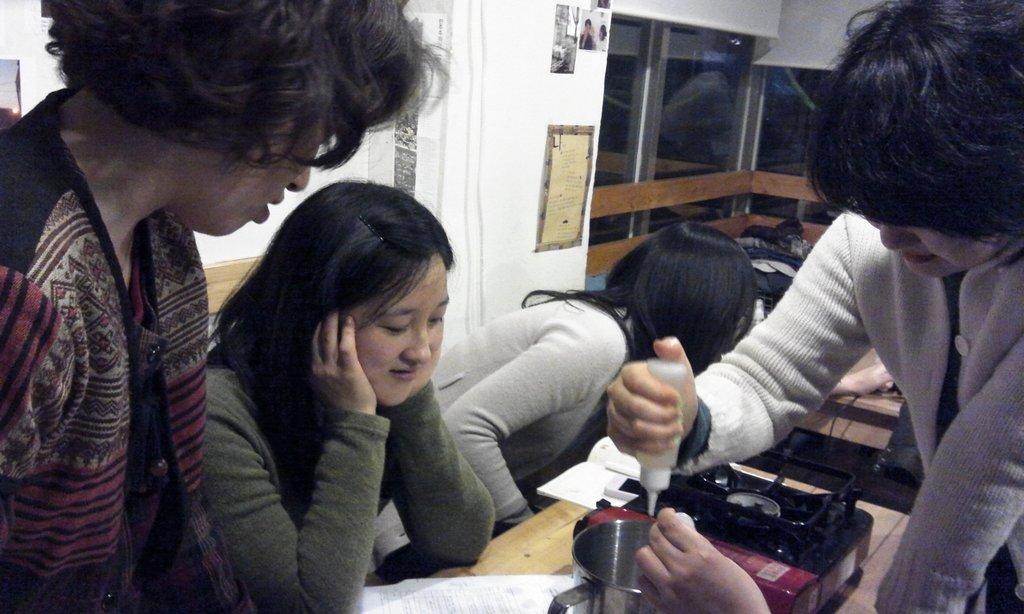In one or two sentences, can you explain what this image depicts? In this image I can see number of people and on the right side I can see one of them is holding a white colour thing. In the centre of this image I can see a table and on it I can see a book, a white colour paper, and equipment and a steel container. In the background I can see few posts on the wall. 